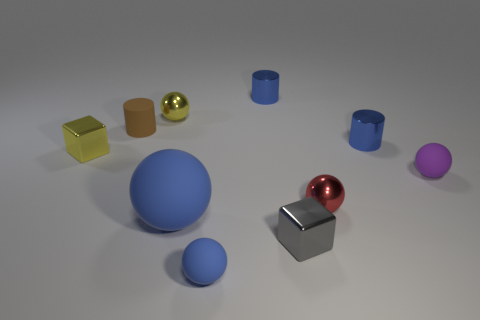There is a ball that is the same color as the large rubber thing; what size is it?
Provide a short and direct response. Small. How many other things are the same size as the matte cylinder?
Your answer should be compact. 8. Is the material of the tiny brown thing that is on the left side of the small purple object the same as the big object?
Offer a terse response. Yes. How many other objects are the same color as the large ball?
Provide a short and direct response. 3. What number of other objects are the same shape as the small brown rubber thing?
Offer a terse response. 2. There is a tiny blue object that is in front of the purple thing; is its shape the same as the tiny yellow object that is behind the yellow block?
Give a very brief answer. Yes. Are there an equal number of red metal spheres that are right of the purple ball and gray blocks that are in front of the large rubber thing?
Offer a very short reply. No. What shape is the blue rubber thing that is to the right of the blue rubber thing behind the tiny rubber sphere that is on the left side of the gray metallic object?
Your response must be concise. Sphere. Is the material of the tiny block behind the purple thing the same as the cube in front of the purple rubber object?
Offer a terse response. Yes. The small yellow shiny object that is to the right of the brown thing has what shape?
Provide a short and direct response. Sphere. 